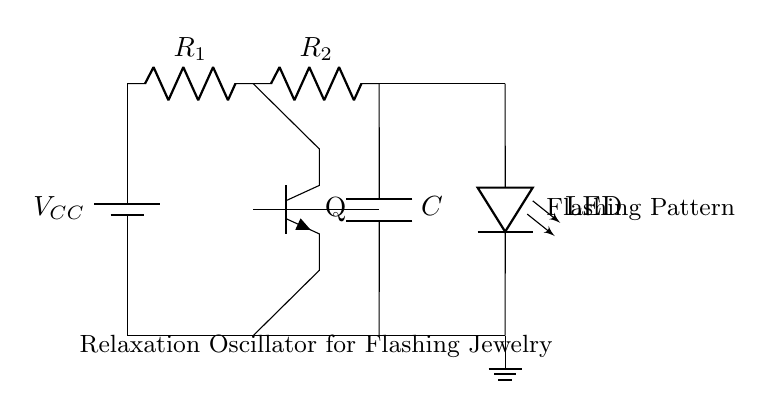What is the type of the main component used in this circuit? The main component is a transistor, which is used as a switch in this relaxation oscillator circuit. It amplifies and switches the current to create the flashing effect.
Answer: transistor How many resistors are in the circuit? There are two resistors labelled as R1 and R2 in the circuit diagram, which are responsible for controlling the charging and discharging of the capacitor, thus influencing the oscillation frequency.
Answer: two What is the purpose of the capacitor in this circuit? The capacitor stores electrical energy and releases it, affecting the timing and frequency of the oscillation. As it charges and discharges, it influences how quickly the LED flashes.
Answer: timing How does the LED receive power in this circuit? The LED receives power through the connections from the transistor and power supply. When the transistor is turned on, current flows through the LED, causing it to flash.
Answer: through the transistor What effect does adjusting R1 or R2 have on the circuit? Adjusting R1 or R2 changes the resistance, which modifies the charge and discharge rates of the capacitor. This, in turn, alters the flashing frequency of the LED, making it faster or slower.
Answer: changes frequency What is the function of the ground in the circuit? The ground serves as the reference point for all voltages in the circuit and provides a return path for current. It ensures stable operation and proper functioning of the components connected.
Answer: reference point What is the output of this relaxation oscillator circuit? The output of this relaxation oscillator circuit is a flashing LED, which indicates the repetitive on-off pattern created by the oscillation of the circuit components.
Answer: flashing LED 